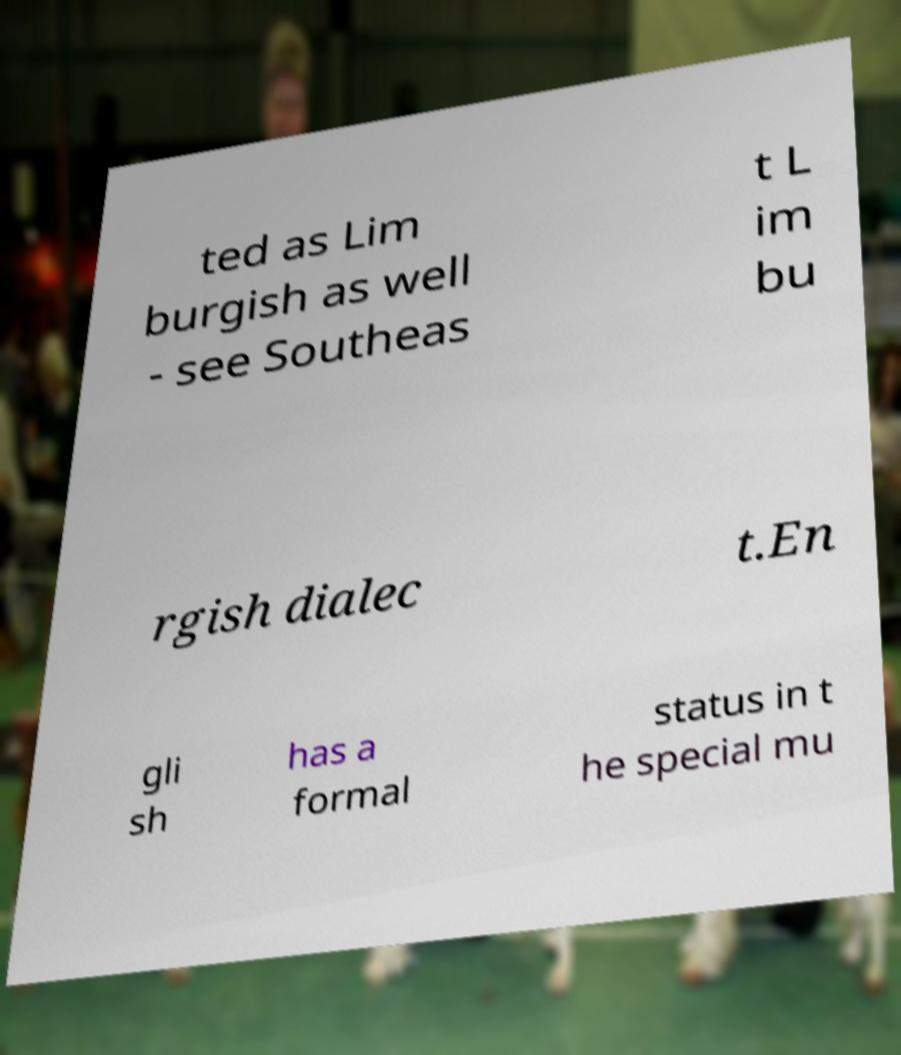What messages or text are displayed in this image? I need them in a readable, typed format. ted as Lim burgish as well - see Southeas t L im bu rgish dialec t.En gli sh has a formal status in t he special mu 